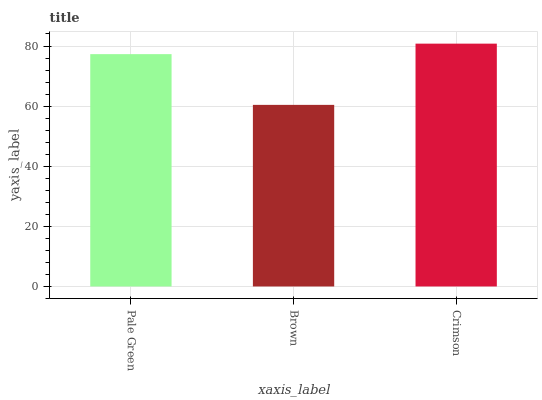Is Brown the minimum?
Answer yes or no. Yes. Is Crimson the maximum?
Answer yes or no. Yes. Is Crimson the minimum?
Answer yes or no. No. Is Brown the maximum?
Answer yes or no. No. Is Crimson greater than Brown?
Answer yes or no. Yes. Is Brown less than Crimson?
Answer yes or no. Yes. Is Brown greater than Crimson?
Answer yes or no. No. Is Crimson less than Brown?
Answer yes or no. No. Is Pale Green the high median?
Answer yes or no. Yes. Is Pale Green the low median?
Answer yes or no. Yes. Is Brown the high median?
Answer yes or no. No. Is Brown the low median?
Answer yes or no. No. 